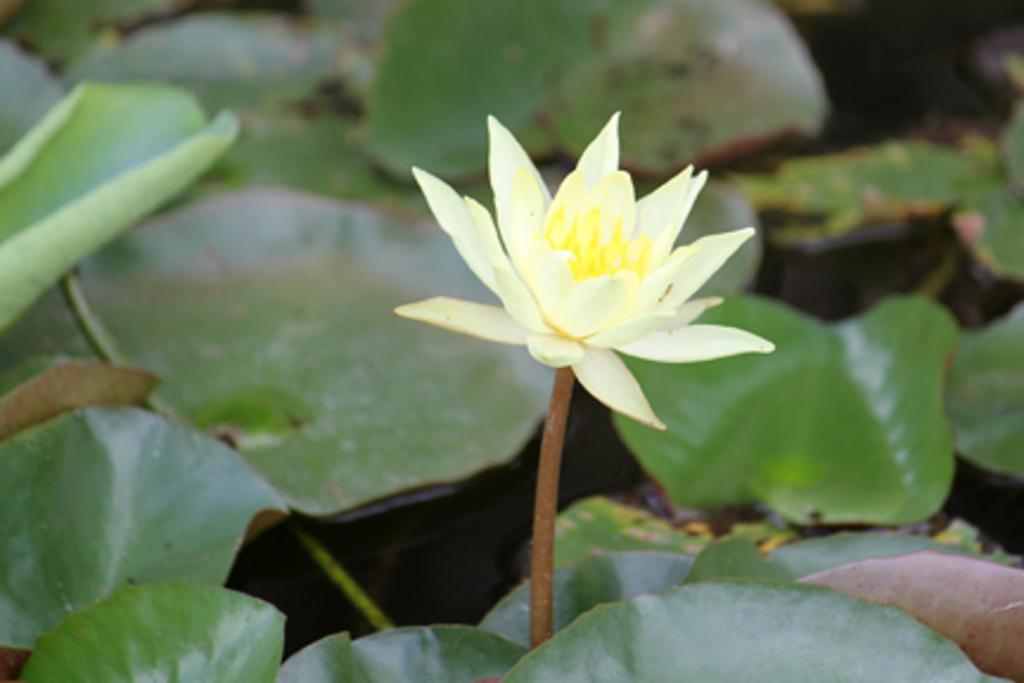What type of flower is in the image? There is a white flower in the image. What else can be seen in the background of the image? There are leaves in the background of the image. Can you describe the leaves in the image? The leaves might be floating on water. How is the background of the image depicted? The background of the image is blurred. What type of brush is used to paint the white flower in the image? There is no indication that the image is a painting, and therefore no brush is used to create it. 